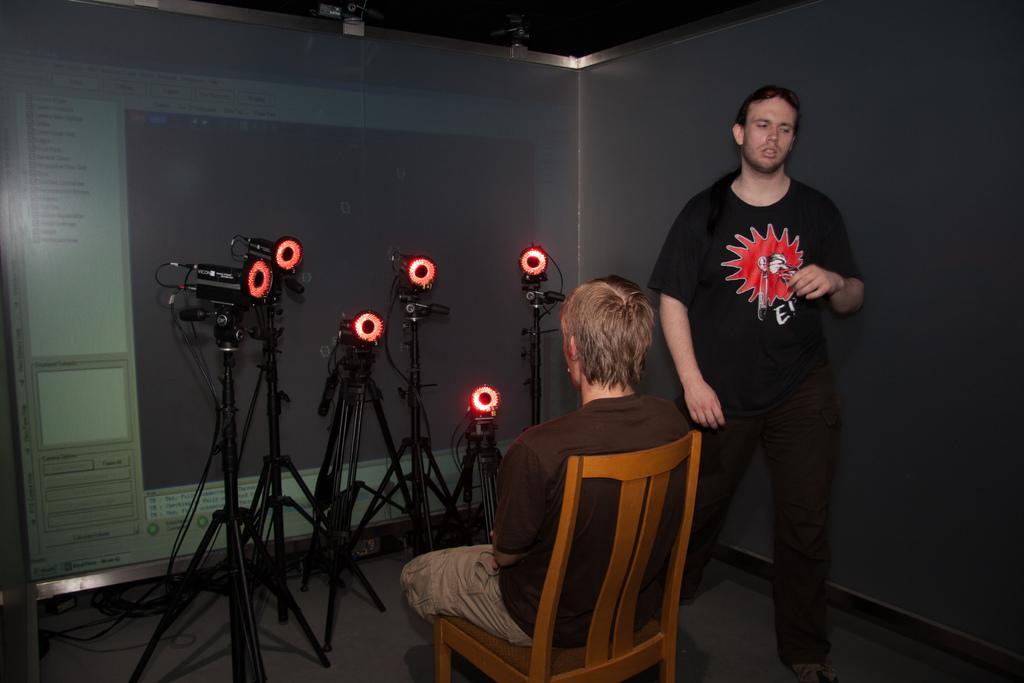Can you describe this image briefly? In this picture there are two people , a brown shirt guy is sitting on a chair. To the opposite of him there are many cameras with red color LED flashing towards him. In the background there is projector screen. 